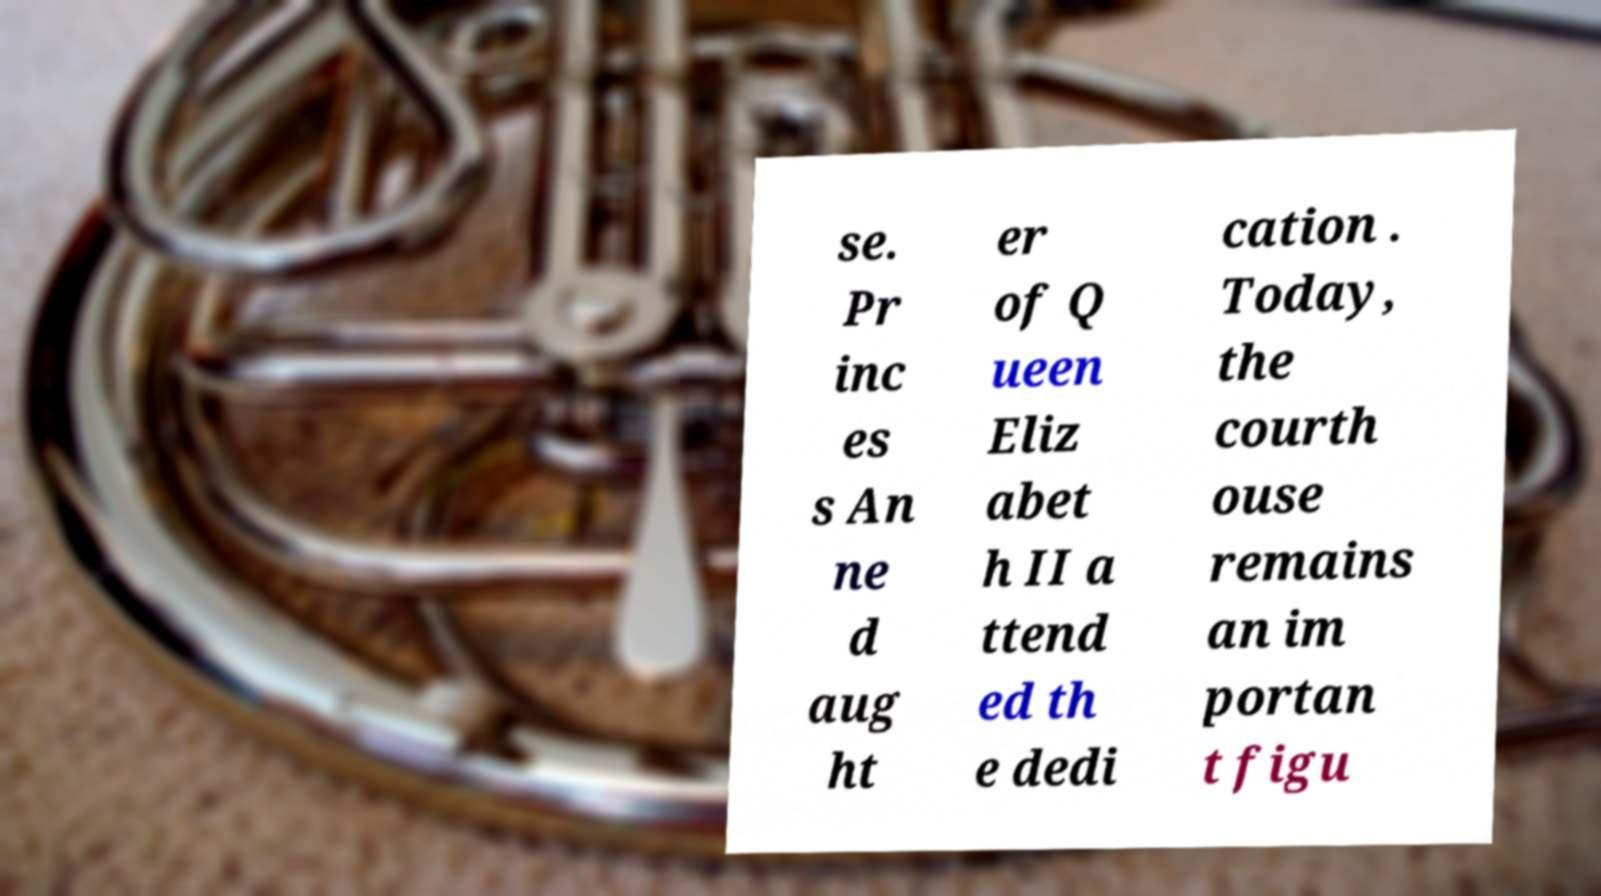Please read and relay the text visible in this image. What does it say? se. Pr inc es s An ne d aug ht er of Q ueen Eliz abet h II a ttend ed th e dedi cation . Today, the courth ouse remains an im portan t figu 